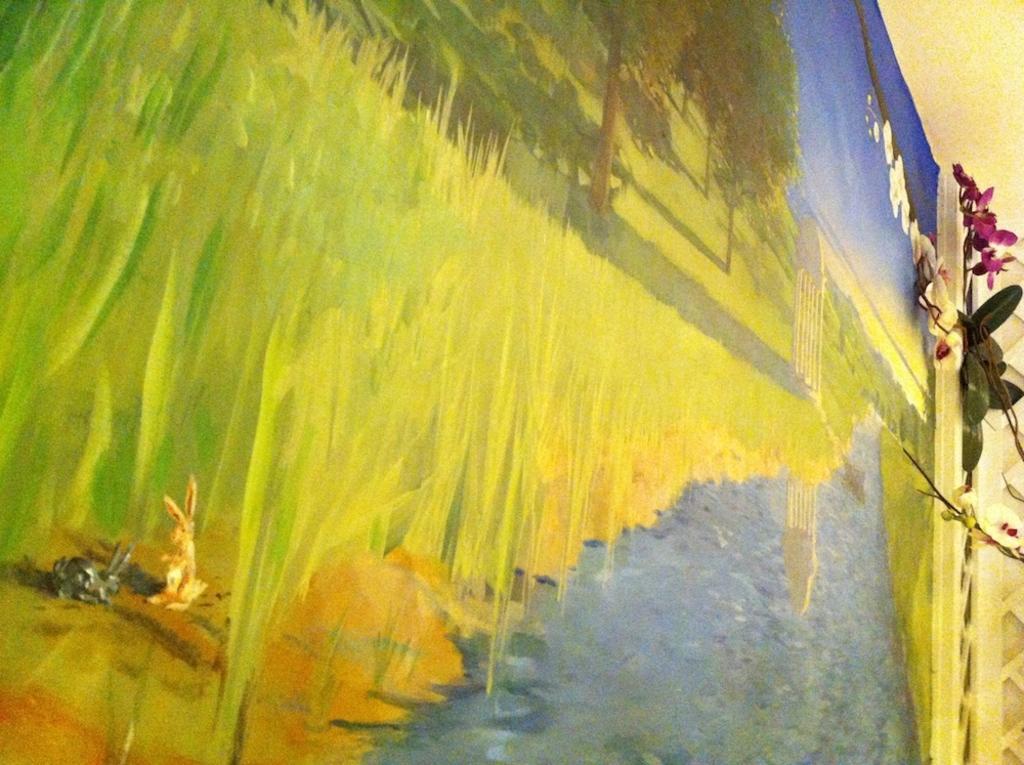Describe this image in one or two sentences. In the image we can see the painting. In the painting we can see water, grass, tree, rabbit and the sky. 